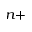<formula> <loc_0><loc_0><loc_500><loc_500>^ { n + }</formula> 